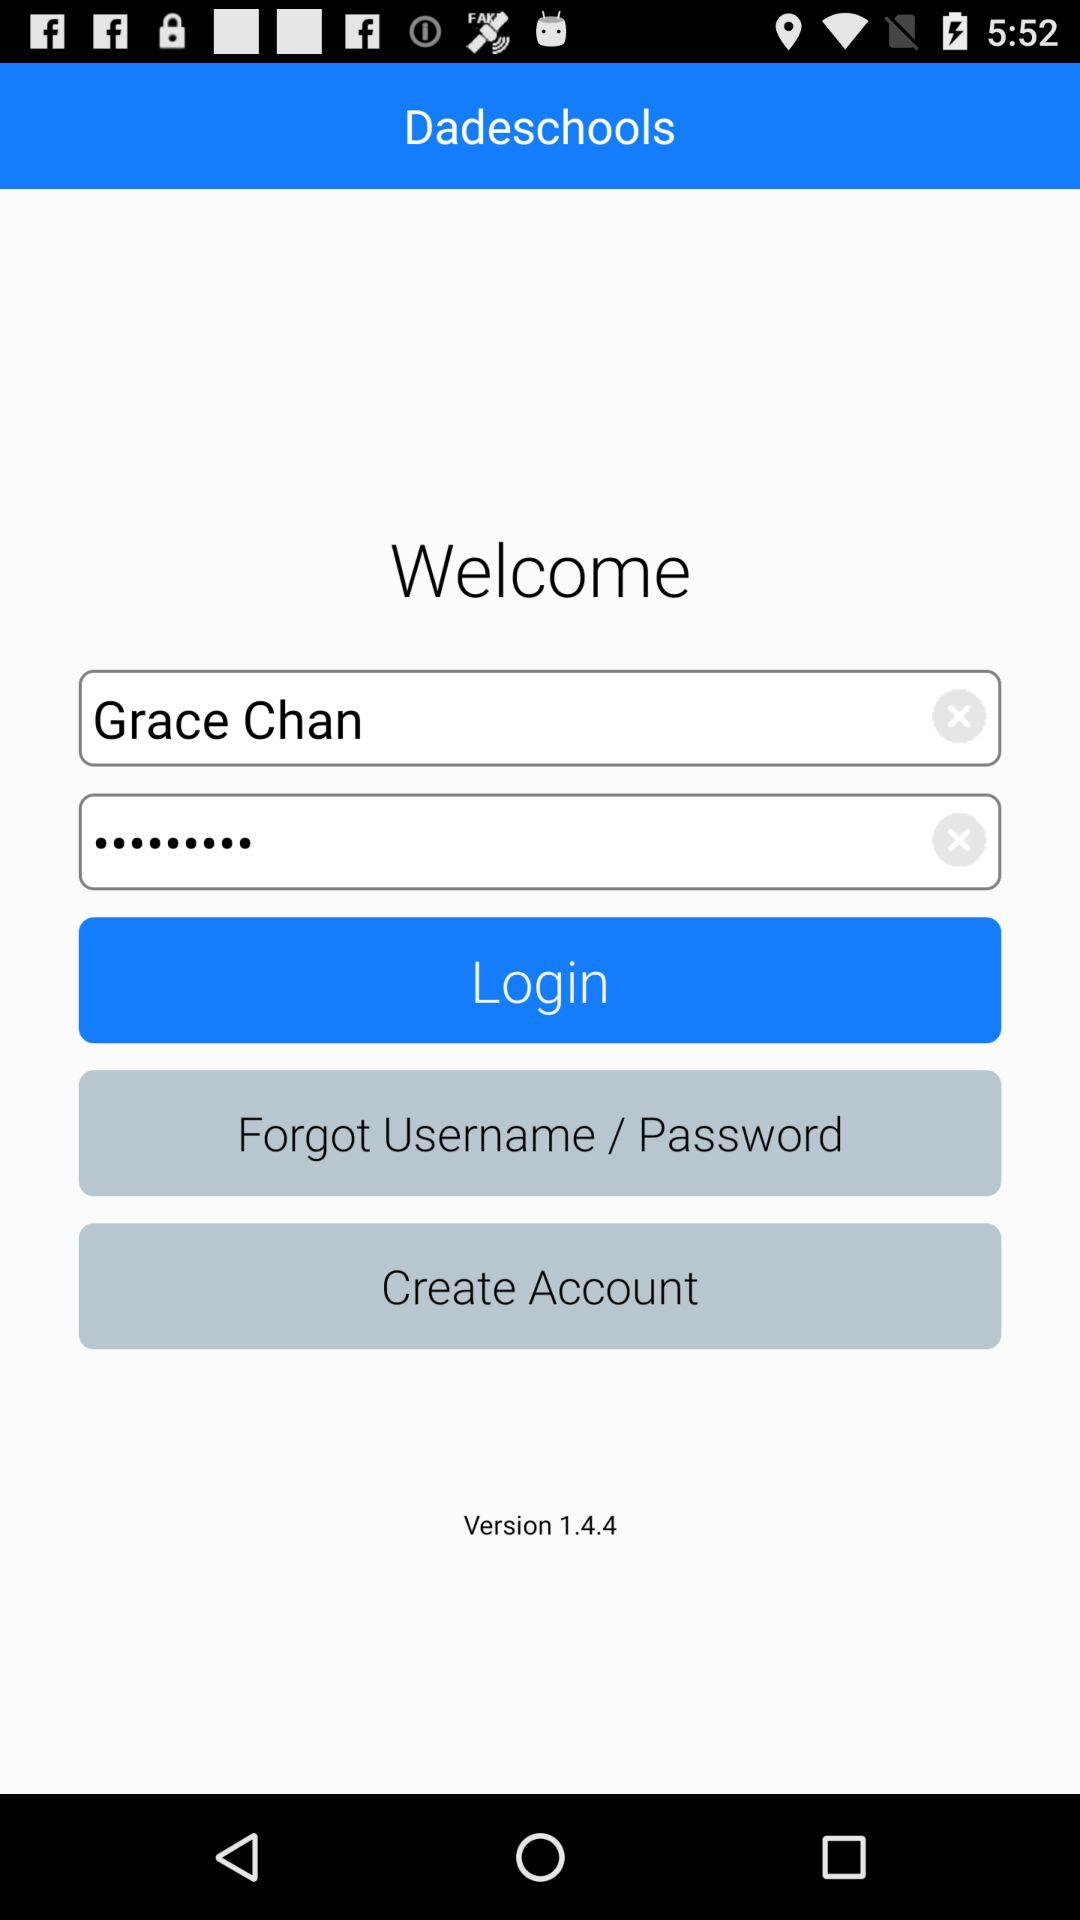What is the version? The version is 1.4.4. 